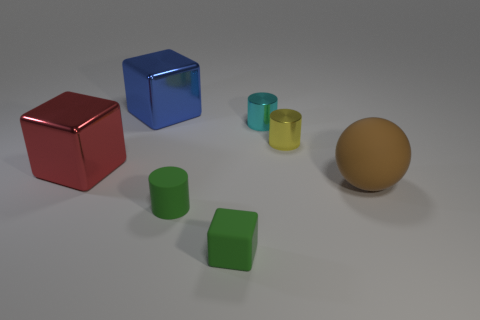Add 1 big balls. How many objects exist? 8 Subtract all balls. How many objects are left? 6 Subtract 0 brown cubes. How many objects are left? 7 Subtract all tiny rubber blocks. Subtract all large brown objects. How many objects are left? 5 Add 6 large blue shiny objects. How many large blue shiny objects are left? 7 Add 3 rubber cylinders. How many rubber cylinders exist? 4 